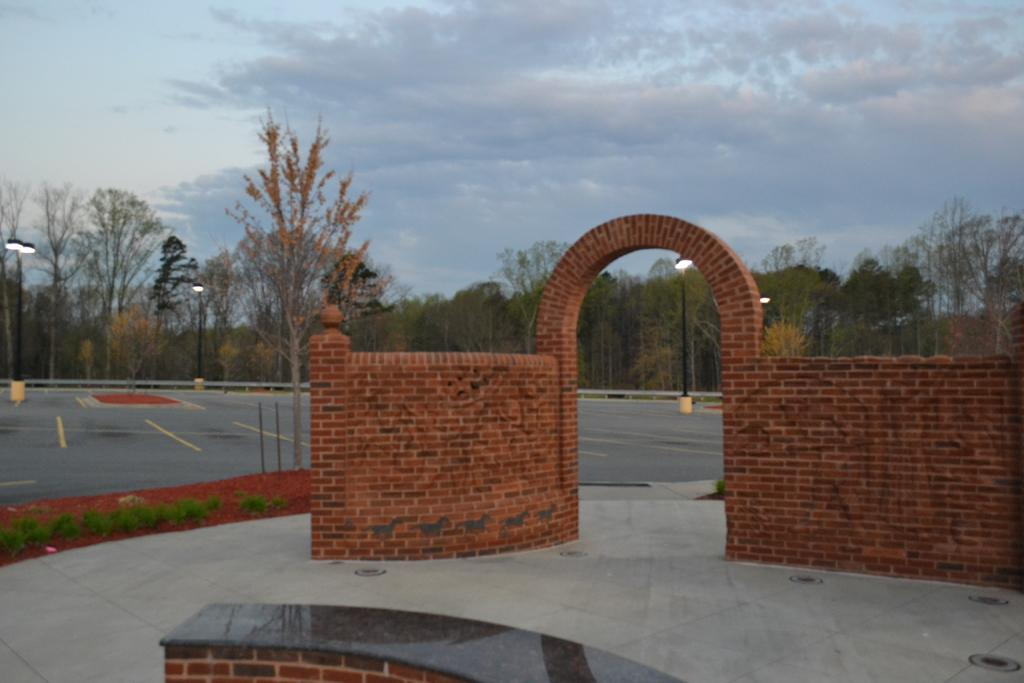What type of structure is visible in the image? There is a brick wall in the image. What can be seen in the background of the image? There are trees and pole lights in the background of the image. What is visible at the top of the image? The sky is visible in the background of the image. How many toes can be seen on the page in the image? There is no page or reference to toes present in the image. 